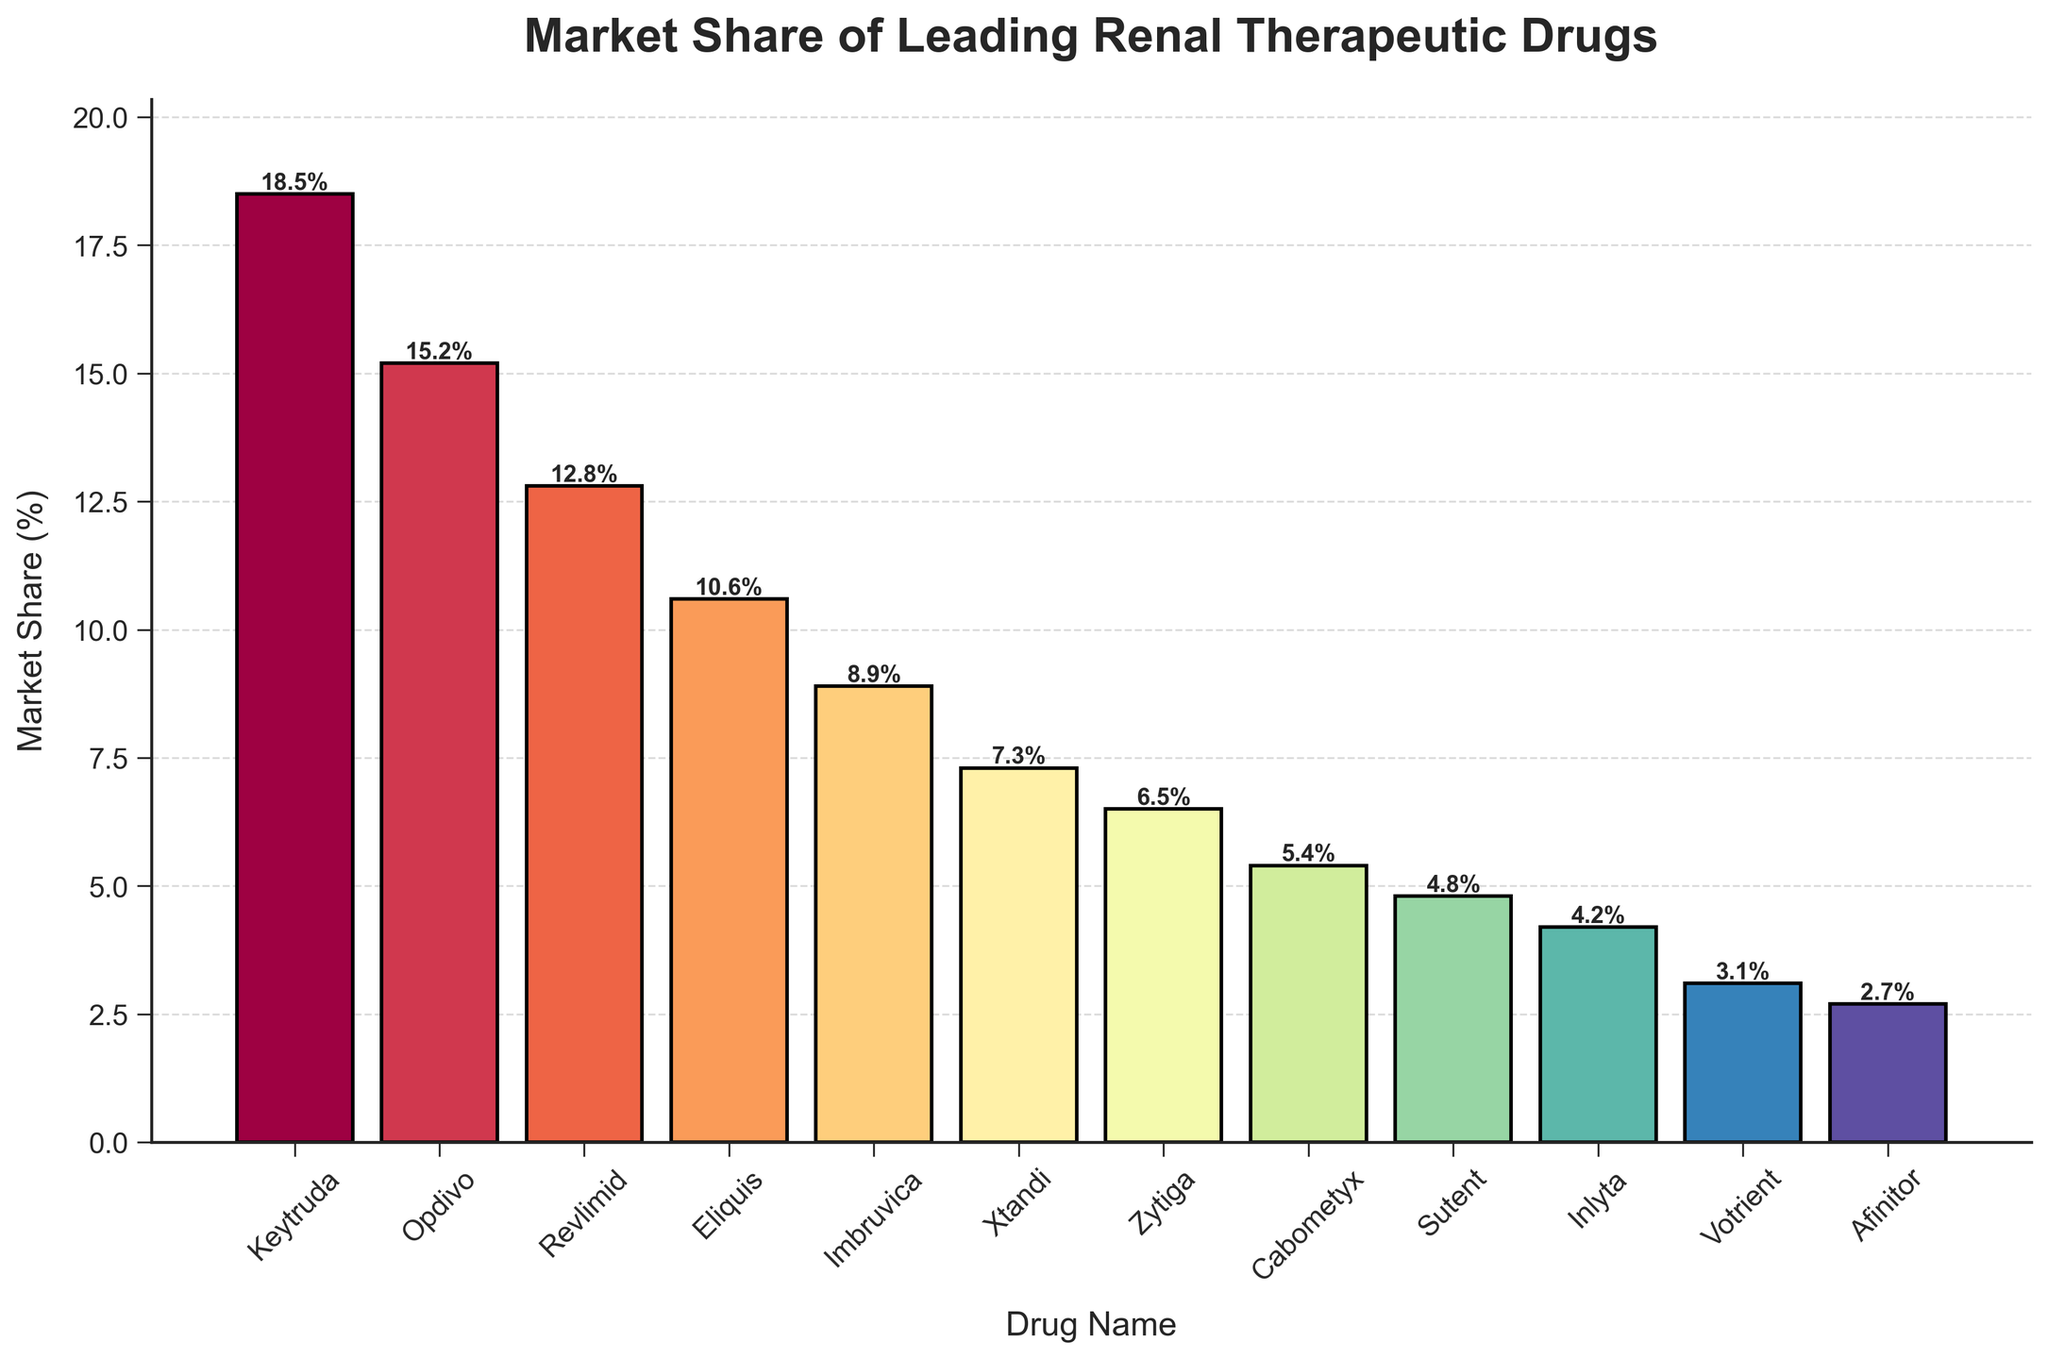What's the drug with the highest market share? To determine the drug with the highest market share, we look for the tallest bar in the chart. The tallest bar corresponds to the drug Keytruda with a market share of 18.5%.
Answer: Keytruda Which drug has a market share closest to 10%? To find the drug with a market share closest to 10%, we look at the bars around the 10% mark. Eliquis has a market share of 10.6%, which is closest to 10%.
Answer: Eliquis What is the combined market share of Opdivo and Revlimid? To find the combined market share, we add the market share percentages of Opdivo (15.2%) and Revlimid (12.8%). The combined market share is 15.2% + 12.8% = 28%.
Answer: 28% Which drug has a lower market share: Sutent or Inlyta? To determine which drug has a lower market share, we compare the heights of the bars for Sutent and Inlyta. Sutent has a market share of 4.8%, and Inlyta has a market share of 4.2%. Therefore, Inlyta has a lower market share than Sutent.
Answer: Inlyta What's the difference in market share between the drug with the highest market share and the drug with the lowest market share? The drug with the highest market share is Keytruda at 18.5%, and the drug with the lowest market share is Afinitor at 2.7%. The difference in market share is 18.5% - 2.7% = 15.8%.
Answer: 15.8% How many drugs have a market share higher than 10%? To find the number of drugs with a market share higher than 10%, we count the bars that exceed the 10% mark. There are four drugs: Keytruda, Opdivo, Revlimid, and Eliquis.
Answer: 4 What's the market share range of the drugs presented in the chart? The market share range is the difference between the highest and lowest market shares. The highest market share is Keytruda at 18.5%, and the lowest is Afinitor at 2.7%. The range is 18.5% - 2.7% = 15.8%.
Answer: 15.8% Which drug ranks fourth in market share? To determine the fourth-ranked drug by market share, we list the drugs in descending order based on their market shares: Keytruda, Opdivo, Revlimid, and Eliquis. Therefore, Eliquis ranks fourth.
Answer: Eliquis What is the average market share of the top three drugs? To calculate the average market share of the top three drugs, we sum their market shares (Keytruda: 18.5%, Opdivo: 15.2%, Revlimid: 12.8%) and divide by three. The average is (18.5 + 15.2 + 12.8) / 3 = 15.5%.
Answer: 15.5% What's the cumulative market share of the bottom five drugs? To find the cumulative market share of the bottom five drugs, we add their market shares (Votrient: 3.1%, Afinitor: 2.7%, Inlyta: 4.2%, Sutent: 4.8%, Cabometyx: 5.4%). The total is 3.1 + 2.7 + 4.2 + 4.8 + 5.4 = 20.2%.
Answer: 20.2% 